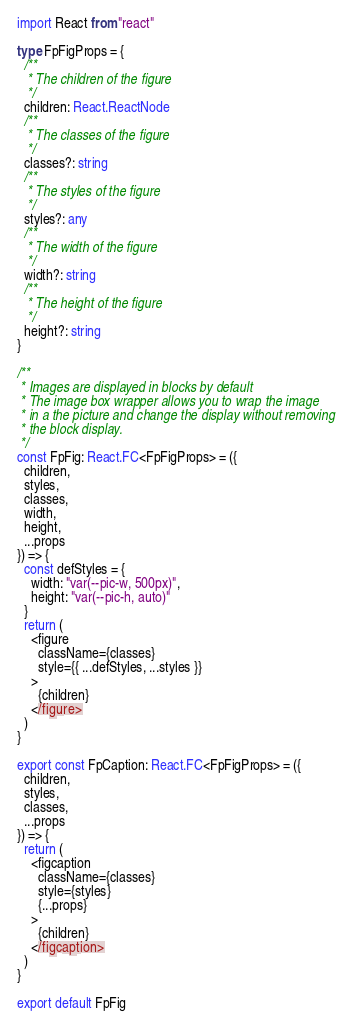Convert code to text. <code><loc_0><loc_0><loc_500><loc_500><_TypeScript_>import React from "react"

type FpFigProps = {
  /**
   * The children of the figure
   */
  children: React.ReactNode
  /**
   * The classes of the figure
   */
  classes?: string
  /**
   * The styles of the figure
   */
  styles?: any
  /**
   * The width of the figure
   */
  width?: string
  /**
   * The height of the figure
   */
  height?: string
}

/**
 * Images are displayed in blocks by default
 * The image box wrapper allows you to wrap the image
 * in a the picture and change the display without removing
 * the block display.
 */
const FpFig: React.FC<FpFigProps> = ({
  children,
  styles,
  classes,
  width,
  height,
  ...props
}) => {
  const defStyles = {
    width: "var(--pic-w, 500px)",
    height: "var(--pic-h, auto)"
  }
  return (
    <figure
      className={classes}
      style={{ ...defStyles, ...styles }}
    >
      {children}
    </figure>
  )
}

export const FpCaption: React.FC<FpFigProps> = ({
  children,
  styles,
  classes,
  ...props
}) => {
  return (
    <figcaption
      className={classes}
      style={styles}
      {...props}
    >
      {children}
    </figcaption>
  )
}

export default FpFig
</code> 